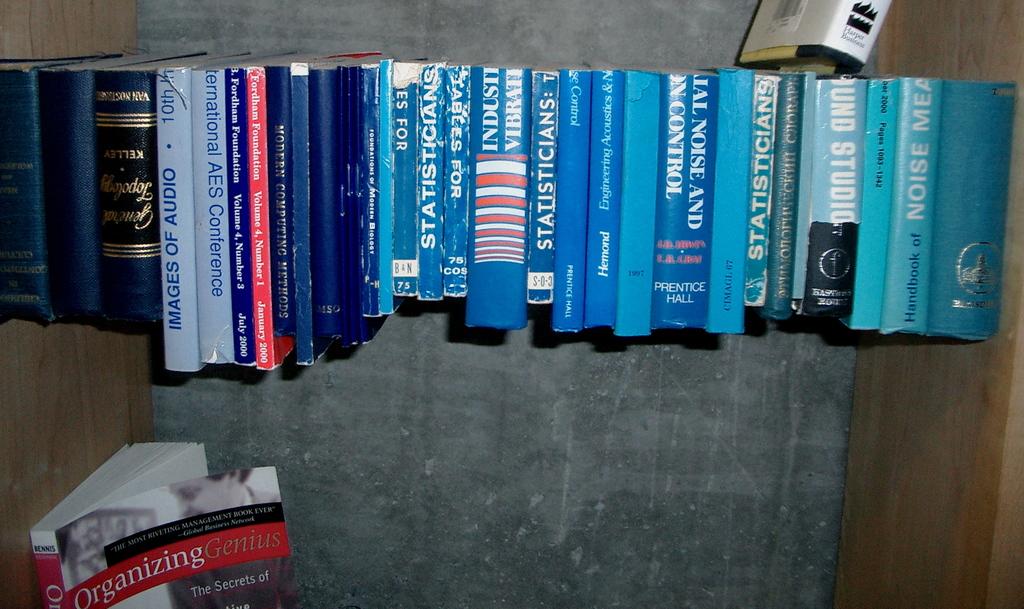What is the white word on the book at the bottom?
Your response must be concise. Organizing. What is the book about that is all by itself?
Make the answer very short. Organizing genius. 